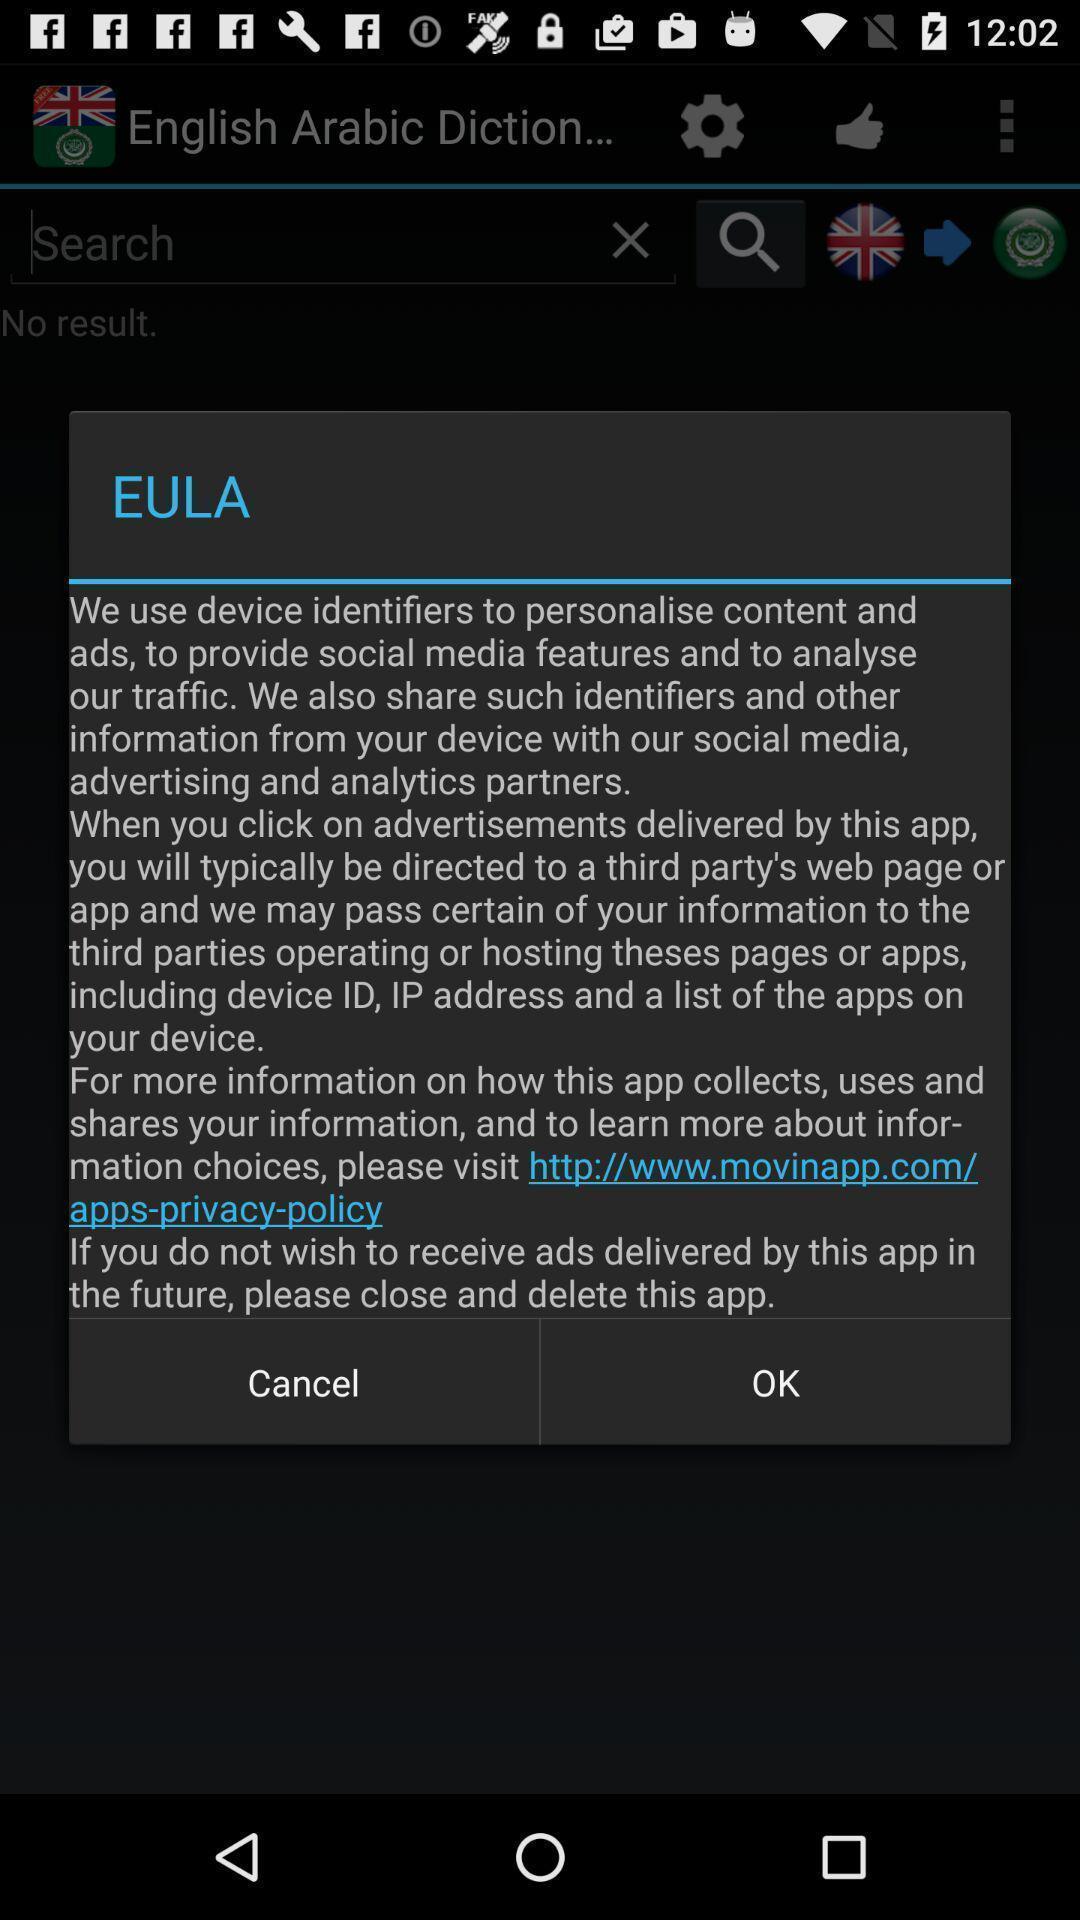Describe the visual elements of this screenshot. Popup of text regarding device information in dictionary app. 